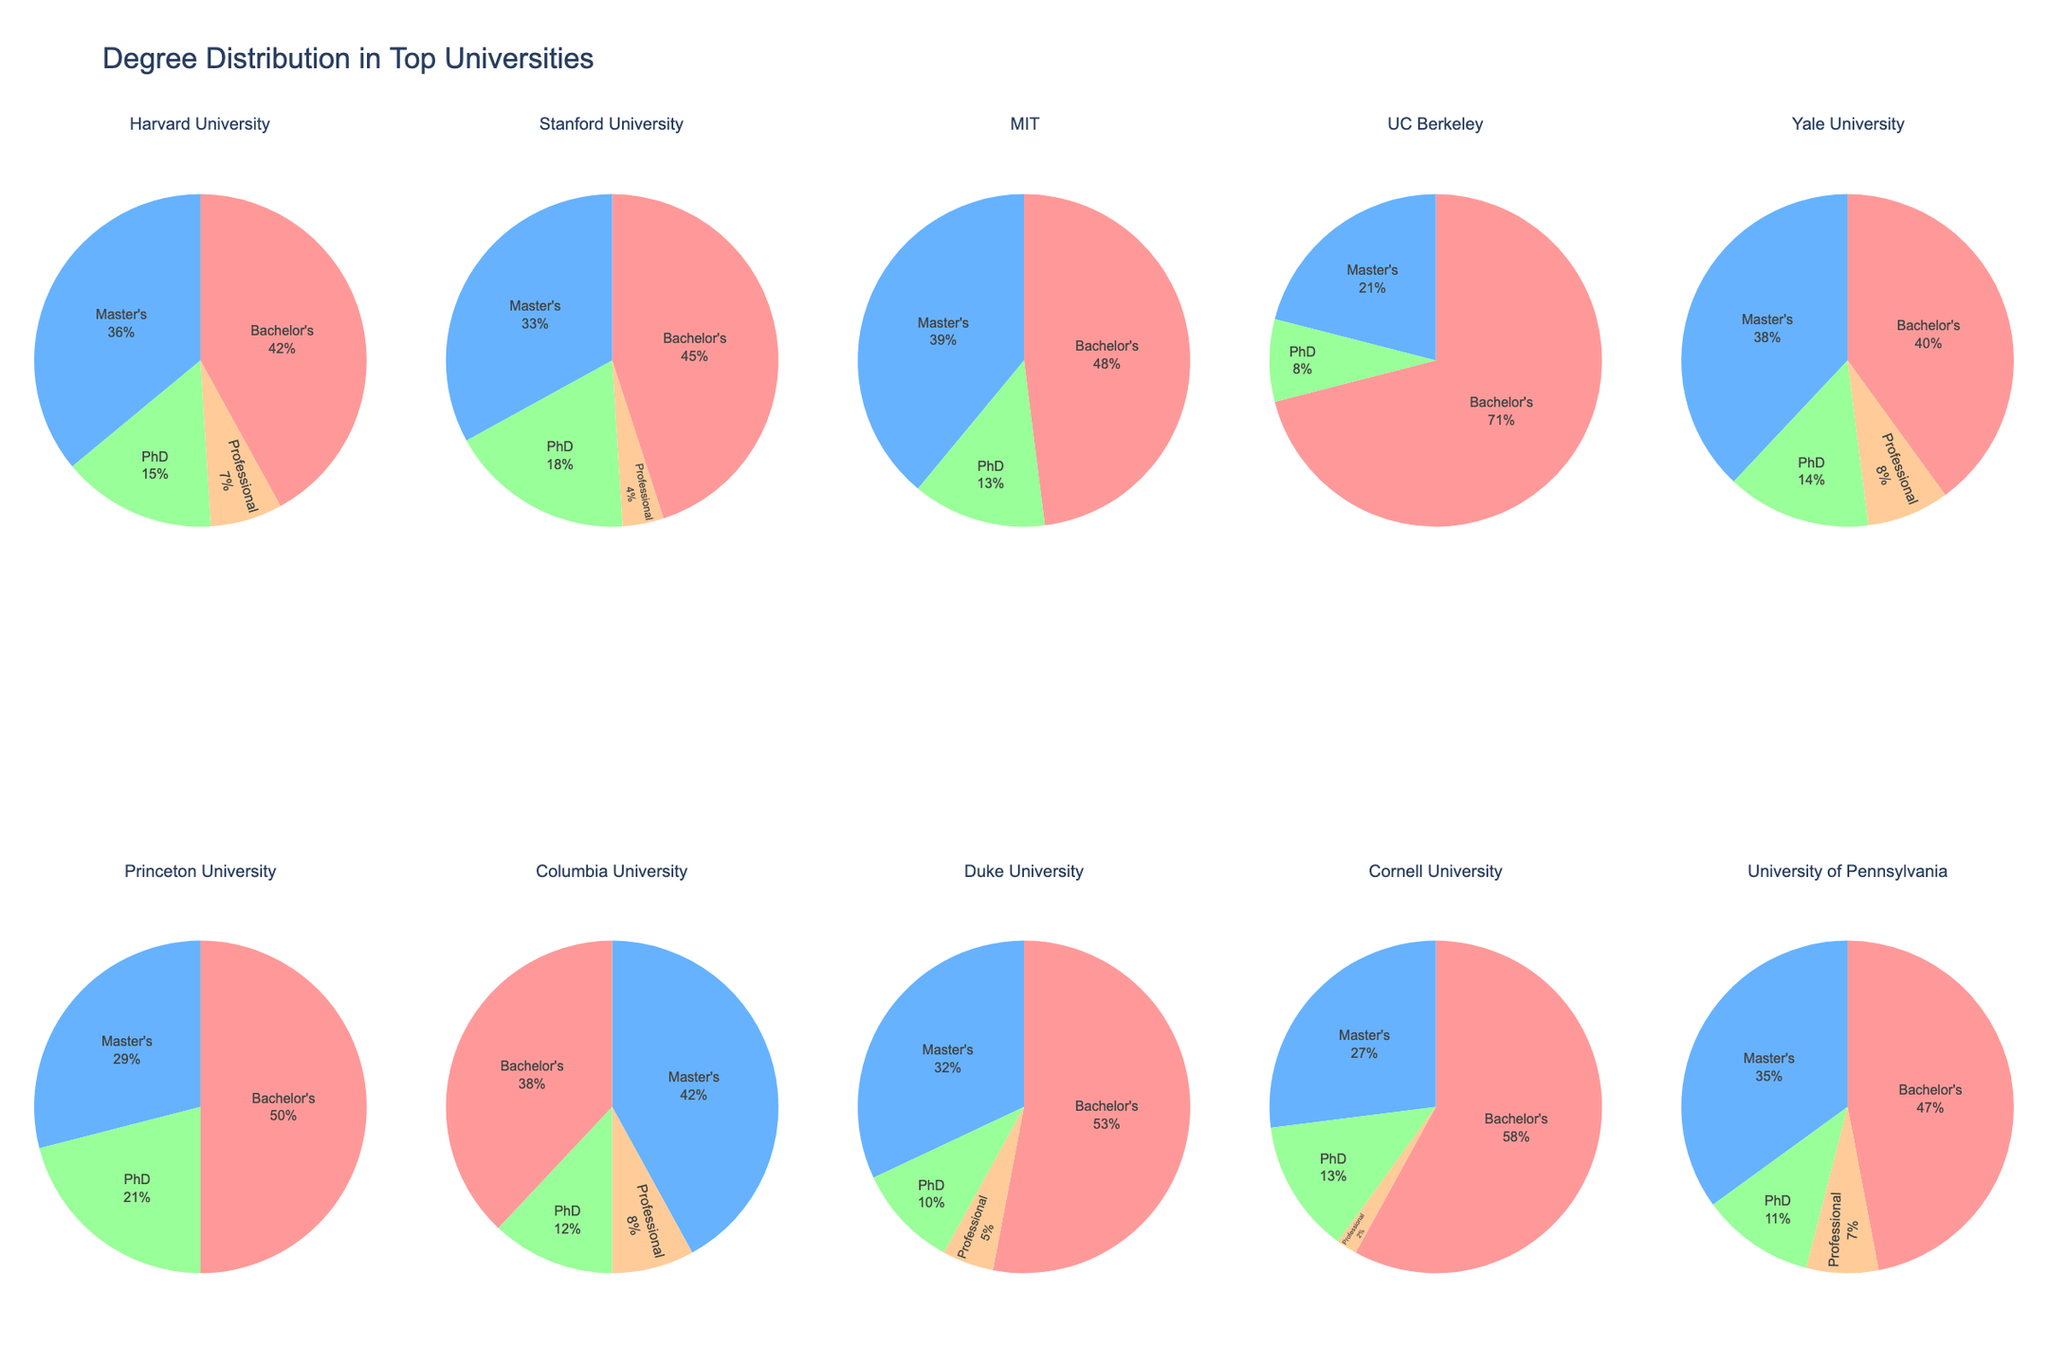Which university has the highest percentage of Bachelor's degree enrollments? To find this, look at each pie chart and compare the sizes of the sections representing Bachelor's degrees. UC Berkeley has the largest slice indicating the highest percentage of Bachelor's enrollments.
Answer: UC Berkeley Which university has the smallest percentage of Professional degree enrollments? Compare the slices for Professional degrees across all the pie charts. MIT has the smallest slice for Professional degrees since it has 0%.
Answer: MIT What is the combined percentage of Master's and Professional degrees at Harvard University? First, identify the percentages in the pie chart of Harvard University. Harvard's Master's is 36% and Professional is 7%. Adding these gives 36% + 7% = 43%.
Answer: 43% Which universities have exactly 8% of their enrollment as PhD students? Scan through the pie charts to find universities where the PhD segment occupies 8% of the chart. UC Berkeley and Columbia University both have 8% PhD enrollments.
Answer: UC Berkeley, Columbia University How does the percentage of Bachelor's degrees at Stanford University compare to Yale University? Check the pie charts for Stanford and Yale. Stanford has 45% for Bachelor's degrees, while Yale has 40%. Therefore, Stanford has a higher percentage.
Answer: Stanford University has a higher percentage Which two universities have the most similar distribution of degrees? By comparing all pie charts, note that Harvard University and Yale University have very similar distributions, both having relatively balanced spreads and similar percentages for each degree type.
Answer: Harvard University and Yale University What percentage of enrollments at Princeton University are PhD students? Look at Princeton's pie chart. The slice representing PhD students is 21%.
Answer: 21% Which university has a higher percentage of Master's degrees, MIT or University of Pennsylvania? Examine the pie charts of both universities. MIT has 39% in Master's degrees, whereas University of Pennsylvania has 35%. MIT has a higher percentage.
Answer: MIT For Columbia University, if you combine the percentages of PhD and Professional degrees, what is the total percentage? In Columbia University's pie chart, PhD is 12% and Professional is 8%. Adding these gives 12% + 8% = 20%.
Answer: 20% On average, what percentage of enrollments do Bachelor's degrees represent across all universities? Calculate the average of the Bachelor's percentages from each pie chart: (42 + 45 + 48 + 71 + 40 + 50 + 38 + 53 + 58 + 47) / 10 = 49.2%.
Answer: 49.2% 